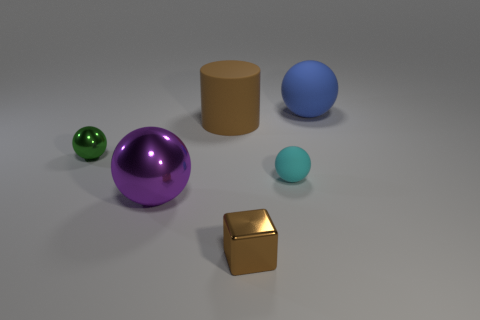Add 1 matte cylinders. How many objects exist? 7 Subtract all cubes. How many objects are left? 5 Subtract all big shiny cubes. Subtract all blue spheres. How many objects are left? 5 Add 1 brown rubber cylinders. How many brown rubber cylinders are left? 2 Add 2 cyan rubber balls. How many cyan rubber balls exist? 3 Subtract 0 blue cubes. How many objects are left? 6 